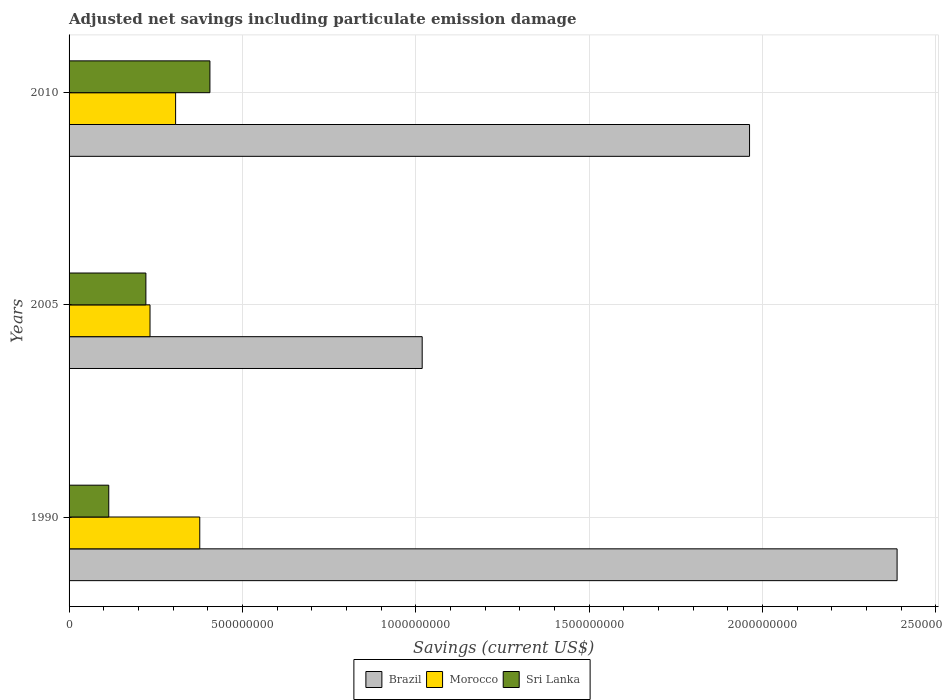Are the number of bars per tick equal to the number of legend labels?
Your answer should be compact. Yes. How many bars are there on the 1st tick from the top?
Your answer should be compact. 3. How many bars are there on the 1st tick from the bottom?
Ensure brevity in your answer.  3. In how many cases, is the number of bars for a given year not equal to the number of legend labels?
Your answer should be compact. 0. What is the net savings in Sri Lanka in 2005?
Provide a short and direct response. 2.22e+08. Across all years, what is the maximum net savings in Brazil?
Your answer should be compact. 2.39e+09. Across all years, what is the minimum net savings in Brazil?
Provide a succinct answer. 1.02e+09. In which year was the net savings in Morocco minimum?
Give a very brief answer. 2005. What is the total net savings in Brazil in the graph?
Your answer should be compact. 5.37e+09. What is the difference between the net savings in Sri Lanka in 2005 and that in 2010?
Keep it short and to the point. -1.85e+08. What is the difference between the net savings in Morocco in 2010 and the net savings in Sri Lanka in 2005?
Your answer should be compact. 8.57e+07. What is the average net savings in Sri Lanka per year?
Ensure brevity in your answer.  2.47e+08. In the year 2005, what is the difference between the net savings in Morocco and net savings in Sri Lanka?
Offer a terse response. 1.19e+07. What is the ratio of the net savings in Brazil in 1990 to that in 2010?
Offer a very short reply. 1.22. Is the net savings in Brazil in 2005 less than that in 2010?
Give a very brief answer. Yes. Is the difference between the net savings in Morocco in 1990 and 2005 greater than the difference between the net savings in Sri Lanka in 1990 and 2005?
Keep it short and to the point. Yes. What is the difference between the highest and the second highest net savings in Morocco?
Give a very brief answer. 6.97e+07. What is the difference between the highest and the lowest net savings in Brazil?
Offer a terse response. 1.37e+09. In how many years, is the net savings in Brazil greater than the average net savings in Brazil taken over all years?
Provide a succinct answer. 2. What does the 2nd bar from the bottom in 2010 represents?
Your answer should be compact. Morocco. Is it the case that in every year, the sum of the net savings in Brazil and net savings in Morocco is greater than the net savings in Sri Lanka?
Make the answer very short. Yes. How many years are there in the graph?
Keep it short and to the point. 3. Are the values on the major ticks of X-axis written in scientific E-notation?
Give a very brief answer. No. Does the graph contain grids?
Make the answer very short. Yes. Where does the legend appear in the graph?
Offer a very short reply. Bottom center. How many legend labels are there?
Ensure brevity in your answer.  3. How are the legend labels stacked?
Provide a succinct answer. Horizontal. What is the title of the graph?
Your answer should be compact. Adjusted net savings including particulate emission damage. What is the label or title of the X-axis?
Keep it short and to the point. Savings (current US$). What is the Savings (current US$) of Brazil in 1990?
Your answer should be compact. 2.39e+09. What is the Savings (current US$) in Morocco in 1990?
Make the answer very short. 3.77e+08. What is the Savings (current US$) in Sri Lanka in 1990?
Your answer should be very brief. 1.15e+08. What is the Savings (current US$) of Brazil in 2005?
Ensure brevity in your answer.  1.02e+09. What is the Savings (current US$) in Morocco in 2005?
Give a very brief answer. 2.33e+08. What is the Savings (current US$) in Sri Lanka in 2005?
Provide a succinct answer. 2.22e+08. What is the Savings (current US$) in Brazil in 2010?
Give a very brief answer. 1.96e+09. What is the Savings (current US$) of Morocco in 2010?
Offer a terse response. 3.07e+08. What is the Savings (current US$) of Sri Lanka in 2010?
Your answer should be very brief. 4.06e+08. Across all years, what is the maximum Savings (current US$) in Brazil?
Provide a short and direct response. 2.39e+09. Across all years, what is the maximum Savings (current US$) in Morocco?
Your response must be concise. 3.77e+08. Across all years, what is the maximum Savings (current US$) in Sri Lanka?
Offer a very short reply. 4.06e+08. Across all years, what is the minimum Savings (current US$) of Brazil?
Provide a succinct answer. 1.02e+09. Across all years, what is the minimum Savings (current US$) of Morocco?
Offer a terse response. 2.33e+08. Across all years, what is the minimum Savings (current US$) in Sri Lanka?
Your response must be concise. 1.15e+08. What is the total Savings (current US$) in Brazil in the graph?
Offer a terse response. 5.37e+09. What is the total Savings (current US$) of Morocco in the graph?
Provide a succinct answer. 9.18e+08. What is the total Savings (current US$) in Sri Lanka in the graph?
Your response must be concise. 7.42e+08. What is the difference between the Savings (current US$) in Brazil in 1990 and that in 2005?
Your answer should be compact. 1.37e+09. What is the difference between the Savings (current US$) in Morocco in 1990 and that in 2005?
Keep it short and to the point. 1.44e+08. What is the difference between the Savings (current US$) in Sri Lanka in 1990 and that in 2005?
Your answer should be very brief. -1.07e+08. What is the difference between the Savings (current US$) of Brazil in 1990 and that in 2010?
Your response must be concise. 4.26e+08. What is the difference between the Savings (current US$) in Morocco in 1990 and that in 2010?
Make the answer very short. 6.97e+07. What is the difference between the Savings (current US$) of Sri Lanka in 1990 and that in 2010?
Ensure brevity in your answer.  -2.92e+08. What is the difference between the Savings (current US$) in Brazil in 2005 and that in 2010?
Provide a short and direct response. -9.44e+08. What is the difference between the Savings (current US$) in Morocco in 2005 and that in 2010?
Keep it short and to the point. -7.38e+07. What is the difference between the Savings (current US$) of Sri Lanka in 2005 and that in 2010?
Provide a succinct answer. -1.85e+08. What is the difference between the Savings (current US$) in Brazil in 1990 and the Savings (current US$) in Morocco in 2005?
Provide a succinct answer. 2.15e+09. What is the difference between the Savings (current US$) of Brazil in 1990 and the Savings (current US$) of Sri Lanka in 2005?
Your response must be concise. 2.17e+09. What is the difference between the Savings (current US$) of Morocco in 1990 and the Savings (current US$) of Sri Lanka in 2005?
Provide a short and direct response. 1.55e+08. What is the difference between the Savings (current US$) of Brazil in 1990 and the Savings (current US$) of Morocco in 2010?
Offer a terse response. 2.08e+09. What is the difference between the Savings (current US$) of Brazil in 1990 and the Savings (current US$) of Sri Lanka in 2010?
Keep it short and to the point. 1.98e+09. What is the difference between the Savings (current US$) in Morocco in 1990 and the Savings (current US$) in Sri Lanka in 2010?
Make the answer very short. -2.93e+07. What is the difference between the Savings (current US$) of Brazil in 2005 and the Savings (current US$) of Morocco in 2010?
Offer a terse response. 7.11e+08. What is the difference between the Savings (current US$) in Brazil in 2005 and the Savings (current US$) in Sri Lanka in 2010?
Offer a terse response. 6.12e+08. What is the difference between the Savings (current US$) of Morocco in 2005 and the Savings (current US$) of Sri Lanka in 2010?
Your answer should be very brief. -1.73e+08. What is the average Savings (current US$) of Brazil per year?
Keep it short and to the point. 1.79e+09. What is the average Savings (current US$) of Morocco per year?
Offer a terse response. 3.06e+08. What is the average Savings (current US$) of Sri Lanka per year?
Ensure brevity in your answer.  2.47e+08. In the year 1990, what is the difference between the Savings (current US$) in Brazil and Savings (current US$) in Morocco?
Offer a very short reply. 2.01e+09. In the year 1990, what is the difference between the Savings (current US$) in Brazil and Savings (current US$) in Sri Lanka?
Offer a very short reply. 2.27e+09. In the year 1990, what is the difference between the Savings (current US$) of Morocco and Savings (current US$) of Sri Lanka?
Offer a very short reply. 2.62e+08. In the year 2005, what is the difference between the Savings (current US$) in Brazil and Savings (current US$) in Morocco?
Keep it short and to the point. 7.85e+08. In the year 2005, what is the difference between the Savings (current US$) of Brazil and Savings (current US$) of Sri Lanka?
Keep it short and to the point. 7.97e+08. In the year 2005, what is the difference between the Savings (current US$) of Morocco and Savings (current US$) of Sri Lanka?
Your response must be concise. 1.19e+07. In the year 2010, what is the difference between the Savings (current US$) of Brazil and Savings (current US$) of Morocco?
Ensure brevity in your answer.  1.66e+09. In the year 2010, what is the difference between the Savings (current US$) in Brazil and Savings (current US$) in Sri Lanka?
Offer a very short reply. 1.56e+09. In the year 2010, what is the difference between the Savings (current US$) in Morocco and Savings (current US$) in Sri Lanka?
Your answer should be compact. -9.90e+07. What is the ratio of the Savings (current US$) of Brazil in 1990 to that in 2005?
Ensure brevity in your answer.  2.34. What is the ratio of the Savings (current US$) of Morocco in 1990 to that in 2005?
Provide a short and direct response. 1.61. What is the ratio of the Savings (current US$) in Sri Lanka in 1990 to that in 2005?
Ensure brevity in your answer.  0.52. What is the ratio of the Savings (current US$) of Brazil in 1990 to that in 2010?
Your response must be concise. 1.22. What is the ratio of the Savings (current US$) in Morocco in 1990 to that in 2010?
Keep it short and to the point. 1.23. What is the ratio of the Savings (current US$) in Sri Lanka in 1990 to that in 2010?
Your answer should be very brief. 0.28. What is the ratio of the Savings (current US$) of Brazil in 2005 to that in 2010?
Ensure brevity in your answer.  0.52. What is the ratio of the Savings (current US$) of Morocco in 2005 to that in 2010?
Your answer should be very brief. 0.76. What is the ratio of the Savings (current US$) in Sri Lanka in 2005 to that in 2010?
Make the answer very short. 0.55. What is the difference between the highest and the second highest Savings (current US$) of Brazil?
Provide a short and direct response. 4.26e+08. What is the difference between the highest and the second highest Savings (current US$) in Morocco?
Your answer should be very brief. 6.97e+07. What is the difference between the highest and the second highest Savings (current US$) of Sri Lanka?
Provide a succinct answer. 1.85e+08. What is the difference between the highest and the lowest Savings (current US$) in Brazil?
Ensure brevity in your answer.  1.37e+09. What is the difference between the highest and the lowest Savings (current US$) in Morocco?
Your answer should be very brief. 1.44e+08. What is the difference between the highest and the lowest Savings (current US$) in Sri Lanka?
Your answer should be very brief. 2.92e+08. 